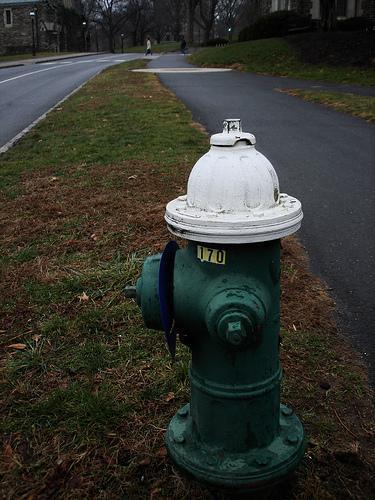How many hydrants are there?
Give a very brief answer. 1. 